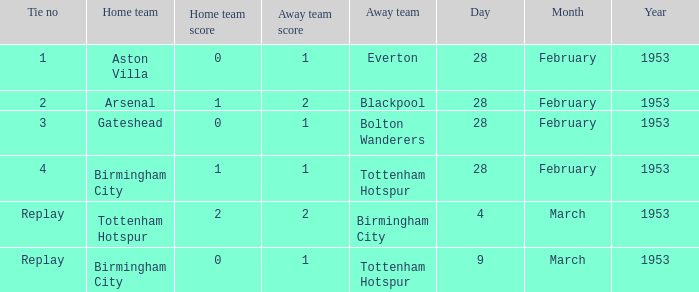Which Score has a Tie no of 1? 0–1. 